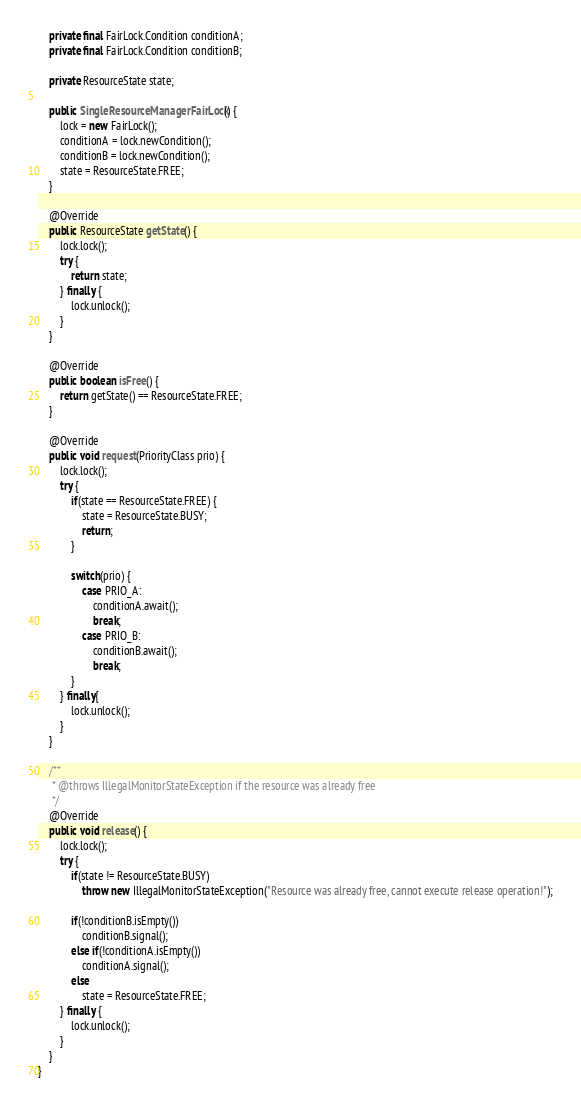<code> <loc_0><loc_0><loc_500><loc_500><_Java_>    private final FairLock.Condition conditionA;
    private final FairLock.Condition conditionB;
    
    private ResourceState state;
    
    public SingleResourceManagerFairLock() {
        lock = new FairLock();
        conditionA = lock.newCondition();
        conditionB = lock.newCondition();
        state = ResourceState.FREE;
    }
    
    @Override
    public ResourceState getState() {
        lock.lock();
        try {
            return state;
        } finally {
            lock.unlock();
        }
    }
    
    @Override
    public boolean isFree() {
        return getState() == ResourceState.FREE;
    }
    
    @Override
    public void request(PriorityClass prio) {
        lock.lock();
        try {
            if(state == ResourceState.FREE) {
                state = ResourceState.BUSY;
                return;
            }
            
            switch(prio) {
                case PRIO_A:
                    conditionA.await();
                    break;
                case PRIO_B:
                    conditionB.await();
                    break;
            }
        } finally{
            lock.unlock();
        }
    }
    
    /**
     * @throws IllegalMonitorStateException if the resource was already free
     */
    @Override
    public void release() {
        lock.lock();
        try {
            if(state != ResourceState.BUSY)
                throw new IllegalMonitorStateException("Resource was already free, cannot execute release operation!");
            
            if(!conditionB.isEmpty())
                conditionB.signal();
            else if(!conditionA.isEmpty())
                conditionA.signal();
            else
                state = ResourceState.FREE;
        } finally {
            lock.unlock();
        }
    }
}
</code> 